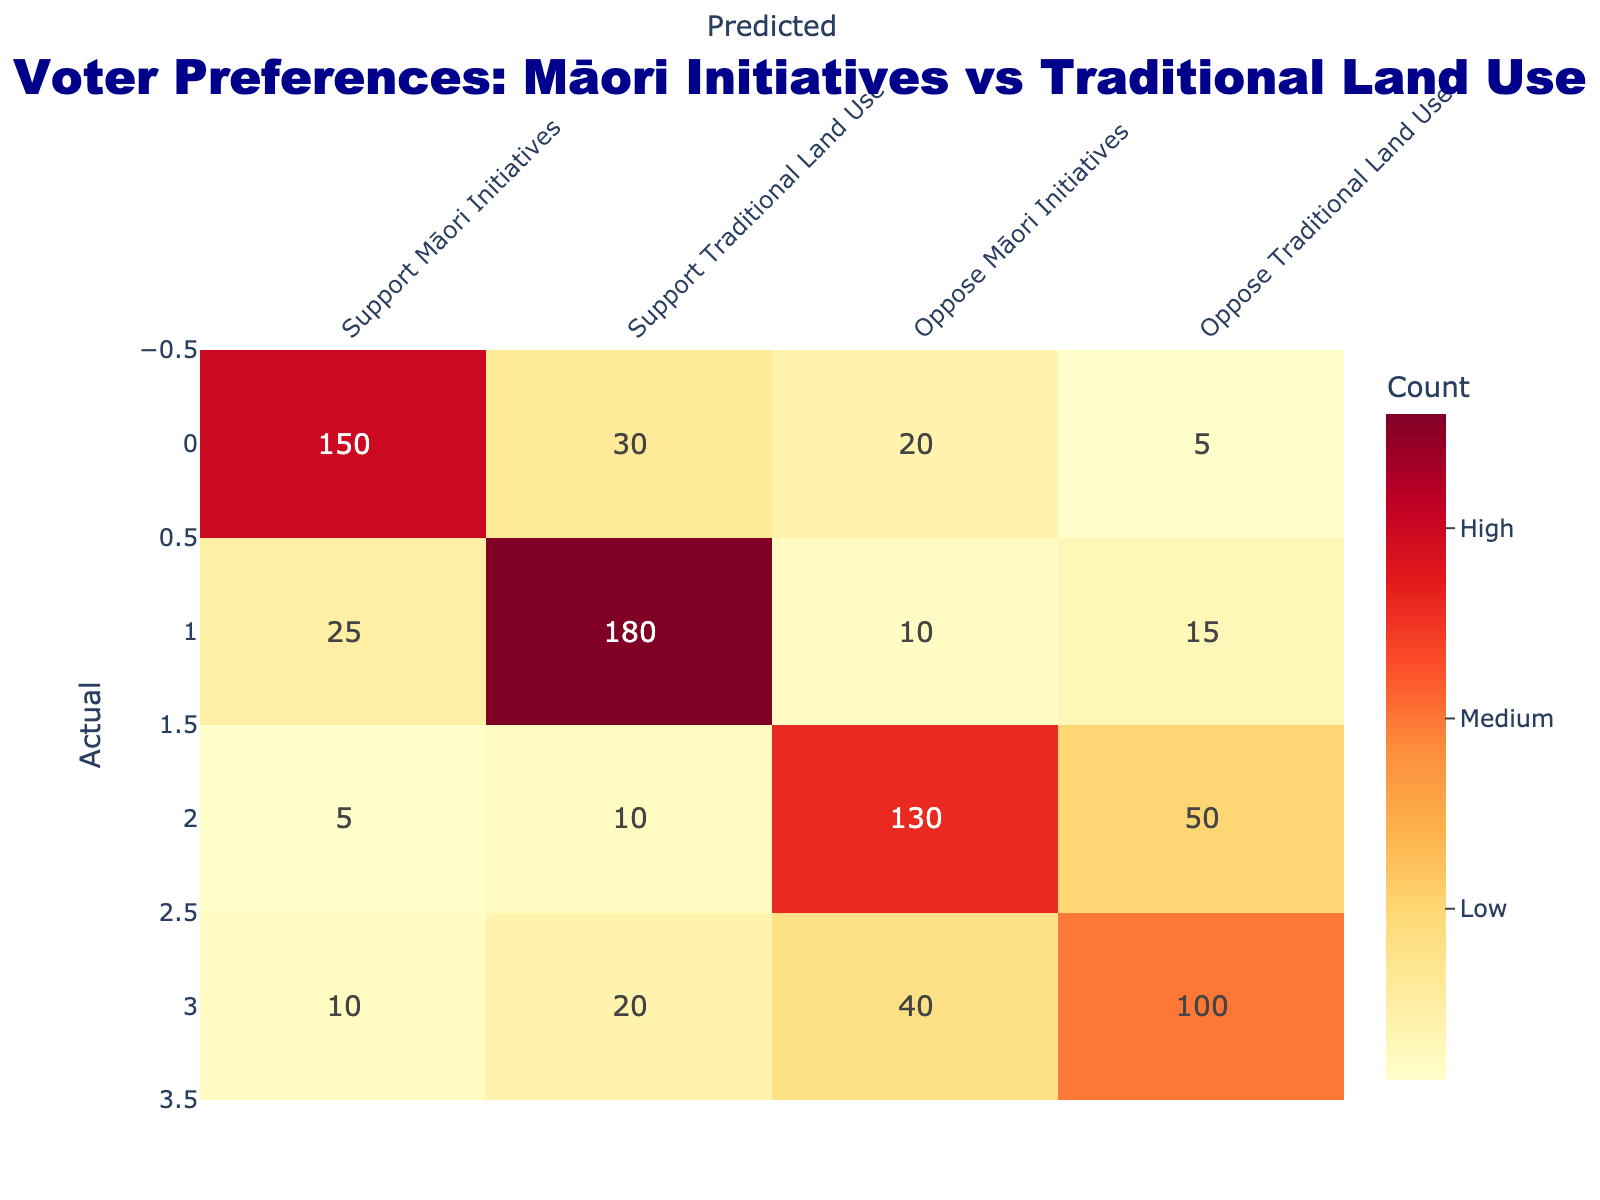What is the total number of respondents who supported Māori initiatives? To find the total number of respondents who supported Māori initiatives, sum the values in the 'Support Māori Initiatives' column: 150 (Support Māori Initiatives) + 30 (Support Traditional Land Use) + 20 (Oppose Māori Initiatives) + 5 (Oppose Traditional Land Use) = 205.
Answer: 205 How many respondents opposed traditional land use who also supported Māori initiatives? From the table, the value in the row for 'Oppose Traditional Land Use' and the column for 'Support Māori Initiatives' is 10. This represents the number of respondents who opposed traditional land use yet supported Māori initiatives.
Answer: 10 Is it true that more people opposed Māori initiatives than supported them? To answer this, we compare the total values for supporters and opposers. The total for supporters of Māori initiatives is 205 (from the previous calculation), while total opposers is 130 (from the 'Oppose Māori Initiatives' row) + 50 (from 'Oppose Traditional Land Use') = 180. Since 205 > 180, the statement is false.
Answer: No What percentage of respondents who opposed Māori initiatives also supported traditional land use? First, identify the number of respondents who opposed Māori initiatives and supported traditional land use, which is 10. Next, find the total number who opposed Māori initiatives: 130 (from 'Oppose Māori Initiatives') + 50 (from 'Oppose Traditional Land Use') = 180. Calculate the percentage: (10 / 180) * 100 = 5.56%.
Answer: 5.56% What is the difference between the number of respondents who supported traditional land use and those who opposed Māori initiatives? The number who supported traditional land use is the total of the 'Support Traditional Land Use' column: 180 (Support Traditional Land Use) + 15 (Oppose Traditional Land Use) = 195. The number who opposed Māori initiatives is 130. The difference is 195 - 130 = 65.
Answer: 65 